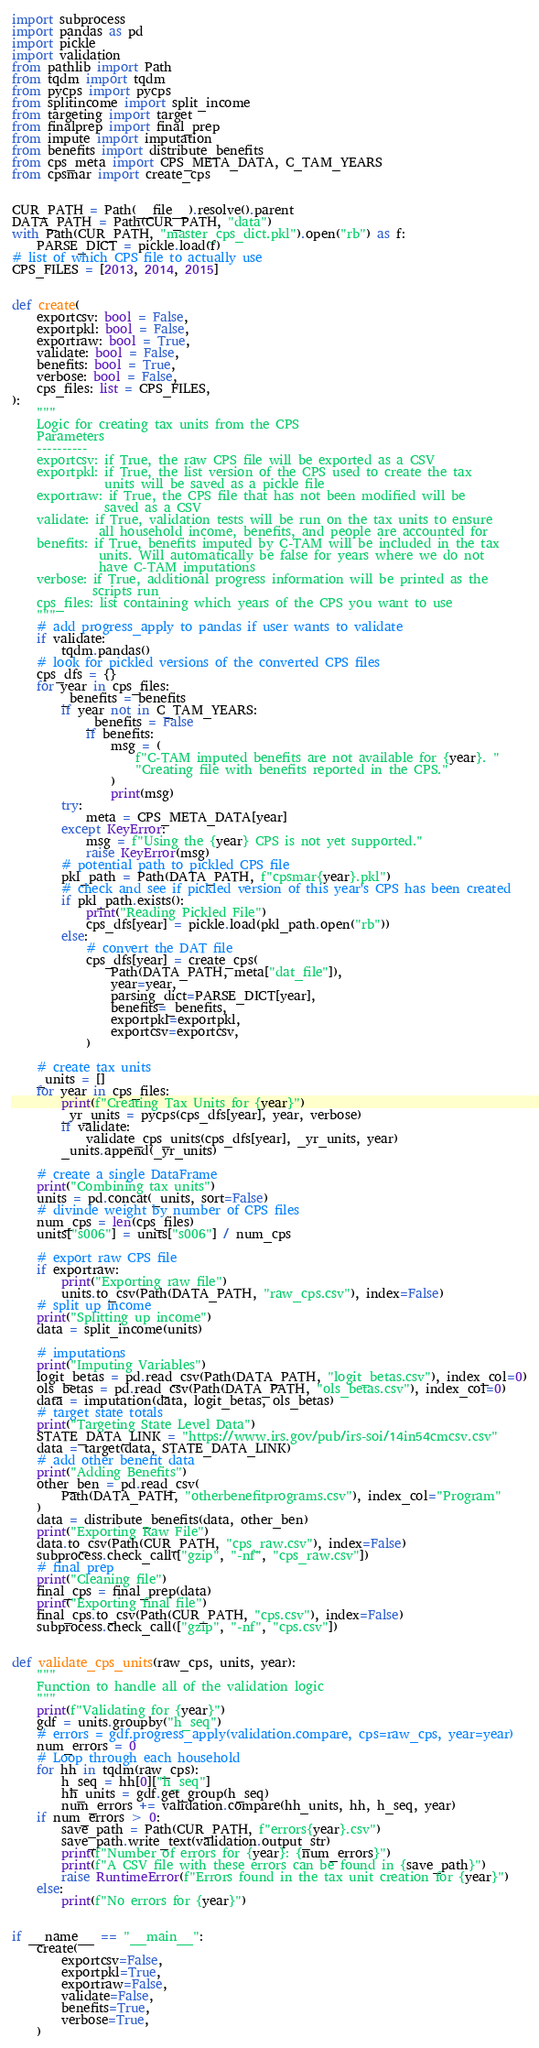<code> <loc_0><loc_0><loc_500><loc_500><_Python_>import subprocess
import pandas as pd
import pickle
import validation
from pathlib import Path
from tqdm import tqdm
from pycps import pycps
from splitincome import split_income
from targeting import target
from finalprep import final_prep
from impute import imputation
from benefits import distribute_benefits
from cps_meta import CPS_META_DATA, C_TAM_YEARS
from cpsmar import create_cps


CUR_PATH = Path(__file__).resolve().parent
DATA_PATH = Path(CUR_PATH, "data")
with Path(CUR_PATH, "master_cps_dict.pkl").open("rb") as f:
    PARSE_DICT = pickle.load(f)
# list of which CPS file to actually use
CPS_FILES = [2013, 2014, 2015]


def create(
    exportcsv: bool = False,
    exportpkl: bool = False,
    exportraw: bool = True,
    validate: bool = False,
    benefits: bool = True,
    verbose: bool = False,
    cps_files: list = CPS_FILES,
):
    """
    Logic for creating tax units from the CPS
    Parameters
    ----------
    exportcsv: if True, the raw CPS file will be exported as a CSV
    exportpkl: if True, the list version of the CPS used to create the tax
               units will be saved as a pickle file
    exportraw: if True, the CPS file that has not been modified will be
               saved as a CSV
    validate: if True, validation tests will be run on the tax units to ensure
              all household income, benefits, and people are accounted for
    benefits: if True, benefits imputed by C-TAM will be included in the tax
              units. Will automatically be false for years where we do not
              have C-TAM imputations
    verbose: if True, additional progress information will be printed as the
             scripts run
    cps_files: list containing which years of the CPS you want to use
    """
    # add progress_apply to pandas if user wants to validate
    if validate:
        tqdm.pandas()
    # look for pickled versions of the converted CPS files
    cps_dfs = {}
    for year in cps_files:
        _benefits = benefits
        if year not in C_TAM_YEARS:
            _benefits = False
            if benefits:
                msg = (
                    f"C-TAM imputed benefits are not available for {year}. "
                    "Creating file with benefits reported in the CPS."
                )
                print(msg)
        try:
            meta = CPS_META_DATA[year]
        except KeyError:
            msg = f"Using the {year} CPS is not yet supported."
            raise KeyError(msg)
        # potential path to pickled CPS file
        pkl_path = Path(DATA_PATH, f"cpsmar{year}.pkl")
        # check and see if pickled version of this year's CPS has been created
        if pkl_path.exists():
            print("Reading Pickled File")
            cps_dfs[year] = pickle.load(pkl_path.open("rb"))
        else:
            # convert the DAT file
            cps_dfs[year] = create_cps(
                Path(DATA_PATH, meta["dat_file"]),
                year=year,
                parsing_dict=PARSE_DICT[year],
                benefits=_benefits,
                exportpkl=exportpkl,
                exportcsv=exportcsv,
            )

    # create tax units
    _units = []
    for year in cps_files:
        print(f"Creating Tax Units for {year}")
        _yr_units = pycps(cps_dfs[year], year, verbose)
        if validate:
            validate_cps_units(cps_dfs[year], _yr_units, year)
        _units.append(_yr_units)

    # create a single DataFrame
    print("Combining tax units")
    units = pd.concat(_units, sort=False)
    # divinde weight by number of CPS files
    num_cps = len(cps_files)
    units["s006"] = units["s006"] / num_cps

    # export raw CPS file
    if exportraw:
        print("Exporting raw file")
        units.to_csv(Path(DATA_PATH, "raw_cps.csv"), index=False)
    # split up income
    print("Splitting up income")
    data = split_income(units)

    # imputations
    print("Imputing Variables")
    logit_betas = pd.read_csv(Path(DATA_PATH, "logit_betas.csv"), index_col=0)
    ols_betas = pd.read_csv(Path(DATA_PATH, "ols_betas.csv"), index_col=0)
    data = imputation(data, logit_betas, ols_betas)
    # target state totals
    print("Targeting State Level Data")
    STATE_DATA_LINK = "https://www.irs.gov/pub/irs-soi/14in54cmcsv.csv"
    data = target(data, STATE_DATA_LINK)
    # add other benefit data
    print("Adding Benefits")
    other_ben = pd.read_csv(
        Path(DATA_PATH, "otherbenefitprograms.csv"), index_col="Program"
    )
    data = distribute_benefits(data, other_ben)
    print("Exporting Raw File")
    data.to_csv(Path(CUR_PATH, "cps_raw.csv"), index=False)
    subprocess.check_call(["gzip", "-nf", "cps_raw.csv"])
    # final prep
    print("Cleaning file")
    final_cps = final_prep(data)
    print("Exporting final file")
    final_cps.to_csv(Path(CUR_PATH, "cps.csv"), index=False)
    subprocess.check_call(["gzip", "-nf", "cps.csv"])


def validate_cps_units(raw_cps, units, year):
    """
    Function to handle all of the validation logic
    """
    print(f"Validating for {year}")
    gdf = units.groupby("h_seq")
    # errors = gdf.progress_apply(validation.compare, cps=raw_cps, year=year)
    num_errors = 0
    # Loop through each household
    for hh in tqdm(raw_cps):
        h_seq = hh[0]["h_seq"]
        hh_units = gdf.get_group(h_seq)
        num_errors += validation.compare(hh_units, hh, h_seq, year)
    if num_errors > 0:
        save_path = Path(CUR_PATH, f"errors{year}.csv")
        save_path.write_text(validation.output_str)
        print(f"Number of errors for {year}: {num_errors}")
        print(f"A CSV file with these errors can be found in {save_path}")
        raise RuntimeError(f"Errors found in the tax unit creation for {year}")
    else:
        print(f"No errors for {year}")


if __name__ == "__main__":
    create(
        exportcsv=False,
        exportpkl=True,
        exportraw=False,
        validate=False,
        benefits=True,
        verbose=True,
    )
</code> 